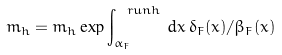Convert formula to latex. <formula><loc_0><loc_0><loc_500><loc_500>\bar { m } _ { h } = m _ { h } \exp \int ^ { \ r u n { h } } _ { \alpha _ { F } } \, d x \, \delta _ { F } ( x ) / \beta _ { F } ( x )</formula> 